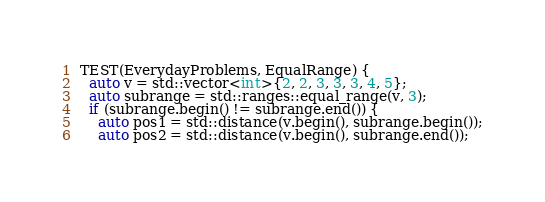Convert code to text. <code><loc_0><loc_0><loc_500><loc_500><_C++_>TEST(EverydayProblems, EqualRange) {
  auto v = std::vector<int>{2, 2, 3, 3, 3, 4, 5};
  auto subrange = std::ranges::equal_range(v, 3);
  if (subrange.begin() != subrange.end()) {
    auto pos1 = std::distance(v.begin(), subrange.begin());
    auto pos2 = std::distance(v.begin(), subrange.end());</code> 